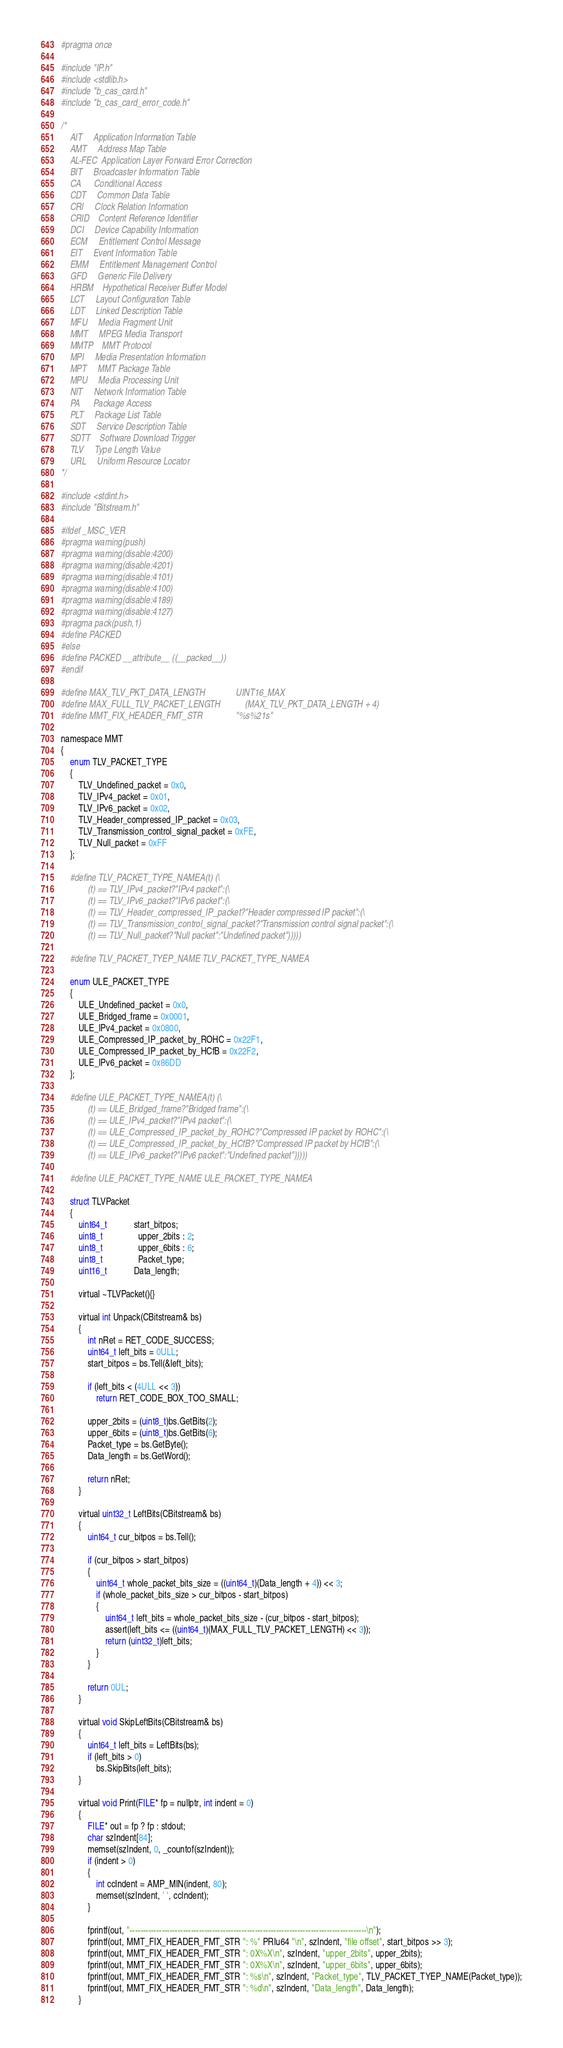Convert code to text. <code><loc_0><loc_0><loc_500><loc_500><_C_>#pragma once

#include "IP.h"
#include <stdlib.h>
#include "b_cas_card.h"
#include "b_cas_card_error_code.h"

/*
	AIT		Application Information Table
	AMT		Address Map Table
	AL-FEC	Application Layer Forward Error Correction
	BIT		Broadcaster Information Table
	CA		Conditional Access
	CDT		Common Data Table
	CRI		Clock Relation Information
	CRID	Content Reference Identifier
	DCI		Device Capability Information
	ECM		Entitlement Control Message
	EIT		Event Information Table
	EMM		Entitlement Management Control
	GFD		Generic File Delivery
	HRBM	Hypothetical Receiver Buffer Model
	LCT		Layout Configuration Table
	LDT		Linked Description Table
	MFU		Media Fragment Unit
	MMT		MPEG Media Transport
	MMTP	MMT Protocol
	MPI		Media Presentation Information
	MPT		MMT Package Table
	MPU		Media Processing Unit
	NIT		Network Information Table
	PA		Package Access
	PLT		Package List Table
	SDT		Service Description Table
	SDTT	Software Download Trigger
	TLV		Type Length Value
	URL		Uniform Resource Locator
*/

#include <stdint.h>
#include "Bitstream.h"

#ifdef _MSC_VER
#pragma warning(push)
#pragma warning(disable:4200)
#pragma warning(disable:4201)
#pragma warning(disable:4101)
#pragma warning(disable:4100)
#pragma warning(disable:4189)
#pragma warning(disable:4127)
#pragma pack(push,1)
#define PACKED
#else
#define PACKED __attribute__ ((__packed__))
#endif

#define MAX_TLV_PKT_DATA_LENGTH				UINT16_MAX
#define MAX_FULL_TLV_PACKET_LENGTH			(MAX_TLV_PKT_DATA_LENGTH + 4)
#define MMT_FIX_HEADER_FMT_STR				"%s%21s"

namespace MMT
{
	enum TLV_PACKET_TYPE
	{
		TLV_Undefined_packet = 0x0,
		TLV_IPv4_packet = 0x01,
		TLV_IPv6_packet = 0x02,
		TLV_Header_compressed_IP_packet = 0x03,
		TLV_Transmission_control_signal_packet = 0xFE,
		TLV_Null_packet = 0xFF
	};

	#define TLV_PACKET_TYPE_NAMEA(t)	(\
			(t) == TLV_IPv4_packet?"IPv4 packet":(\
			(t) == TLV_IPv6_packet?"IPv6 packet":(\
			(t) == TLV_Header_compressed_IP_packet?"Header compressed IP packet":(\
			(t) == TLV_Transmission_control_signal_packet?"Transmission control signal packet":(\
			(t) == TLV_Null_packet?"Null packet":"Undefined packet")))))

	#define TLV_PACKET_TYEP_NAME	TLV_PACKET_TYPE_NAMEA

	enum ULE_PACKET_TYPE
	{
		ULE_Undefined_packet = 0x0,
		ULE_Bridged_frame = 0x0001,
		ULE_IPv4_packet = 0x0800,
		ULE_Compressed_IP_packet_by_ROHC = 0x22F1,
		ULE_Compressed_IP_packet_by_HCfB = 0x22F2,
		ULE_IPv6_packet = 0x86DD
	};

	#define ULE_PACKET_TYPE_NAMEA(t)	(\
			(t) == ULE_Bridged_frame?"Bridged frame":(\
			(t) == ULE_IPv4_packet?"IPv4 packet":(\
			(t) == ULE_Compressed_IP_packet_by_ROHC?"Compressed IP packet by ROHC":(\
			(t) == ULE_Compressed_IP_packet_by_HCfB?"Compressed IP packet by HCfB":(\
			(t) == ULE_IPv6_packet?"IPv6 packet":"Undefined packet")))))

	#define ULE_PACKET_TYPE_NAME	ULE_PACKET_TYPE_NAMEA

	struct TLVPacket
	{
		uint64_t			start_bitpos;
		uint8_t				upper_2bits : 2;
		uint8_t				upper_6bits : 6;
		uint8_t				Packet_type;
		uint16_t			Data_length;

		virtual ~TLVPacket(){}

		virtual int Unpack(CBitstream& bs)
		{
			int nRet = RET_CODE_SUCCESS;
			uint64_t left_bits = 0ULL;
			start_bitpos = bs.Tell(&left_bits);

			if (left_bits < (4ULL << 3))
				return RET_CODE_BOX_TOO_SMALL;

			upper_2bits = (uint8_t)bs.GetBits(2);
			upper_6bits = (uint8_t)bs.GetBits(6);
			Packet_type = bs.GetByte();
			Data_length = bs.GetWord();

			return nRet;
		}

		virtual uint32_t LeftBits(CBitstream& bs)
		{
			uint64_t cur_bitpos = bs.Tell();

			if (cur_bitpos > start_bitpos)
			{
				uint64_t whole_packet_bits_size = ((uint64_t)(Data_length + 4)) << 3;
				if (whole_packet_bits_size > cur_bitpos - start_bitpos)
				{
					uint64_t left_bits = whole_packet_bits_size - (cur_bitpos - start_bitpos);
					assert(left_bits <= ((uint64_t)(MAX_FULL_TLV_PACKET_LENGTH) << 3));
					return (uint32_t)left_bits;
				}
			}

			return 0UL;
		}

		virtual void SkipLeftBits(CBitstream& bs)
		{
			uint64_t left_bits = LeftBits(bs);
			if (left_bits > 0)
				bs.SkipBits(left_bits);
		}

		virtual void Print(FILE* fp = nullptr, int indent = 0)
		{
			FILE* out = fp ? fp : stdout;
			char szIndent[84];
			memset(szIndent, 0, _countof(szIndent));
			if (indent > 0)
			{
				int ccIndent = AMP_MIN(indent, 80);
				memset(szIndent, ' ', ccIndent);
			}

			fprintf(out, "-----------------------------------------------------------------------------------------\n");
			fprintf(out, MMT_FIX_HEADER_FMT_STR ": %" PRIu64 "\n", szIndent, "file offset", start_bitpos >> 3);
			fprintf(out, MMT_FIX_HEADER_FMT_STR ": 0X%X\n", szIndent, "upper_2bits", upper_2bits);
			fprintf(out, MMT_FIX_HEADER_FMT_STR ": 0X%X\n", szIndent, "upper_6bits", upper_6bits);
			fprintf(out, MMT_FIX_HEADER_FMT_STR ": %s\n", szIndent, "Packet_type", TLV_PACKET_TYEP_NAME(Packet_type));
			fprintf(out, MMT_FIX_HEADER_FMT_STR ": %d\n", szIndent, "Data_length", Data_length);
		}
</code> 